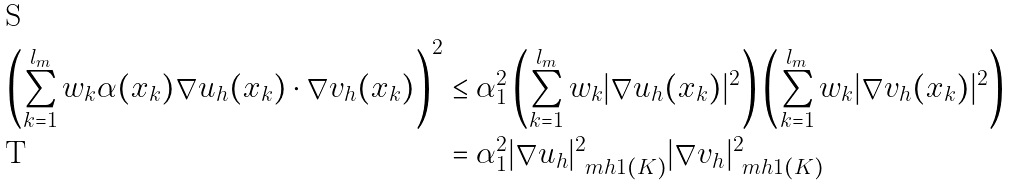<formula> <loc_0><loc_0><loc_500><loc_500>\left ( \sum _ { k = 1 } ^ { l _ { m } } w _ { k } \alpha ( x _ { k } ) \nabla u _ { h } ( x _ { k } ) \cdot \nabla v _ { h } ( x _ { k } ) \right ) ^ { 2 } & \leq \alpha _ { 1 } ^ { 2 } \left ( \sum _ { k = 1 } ^ { l _ { m } } w _ { k } | \nabla u _ { h } ( x _ { k } ) | ^ { 2 } \right ) \left ( \sum _ { k = 1 } ^ { l _ { m } } w _ { k } | \nabla v _ { h } ( x _ { k } ) | ^ { 2 } \right ) \\ & = \alpha _ { 1 } ^ { 2 } | \nabla u _ { h } | ^ { 2 } _ { \ m { h 1 } ( K ) } | \nabla v _ { h } | ^ { 2 } _ { \ m { h 1 } ( K ) }</formula> 